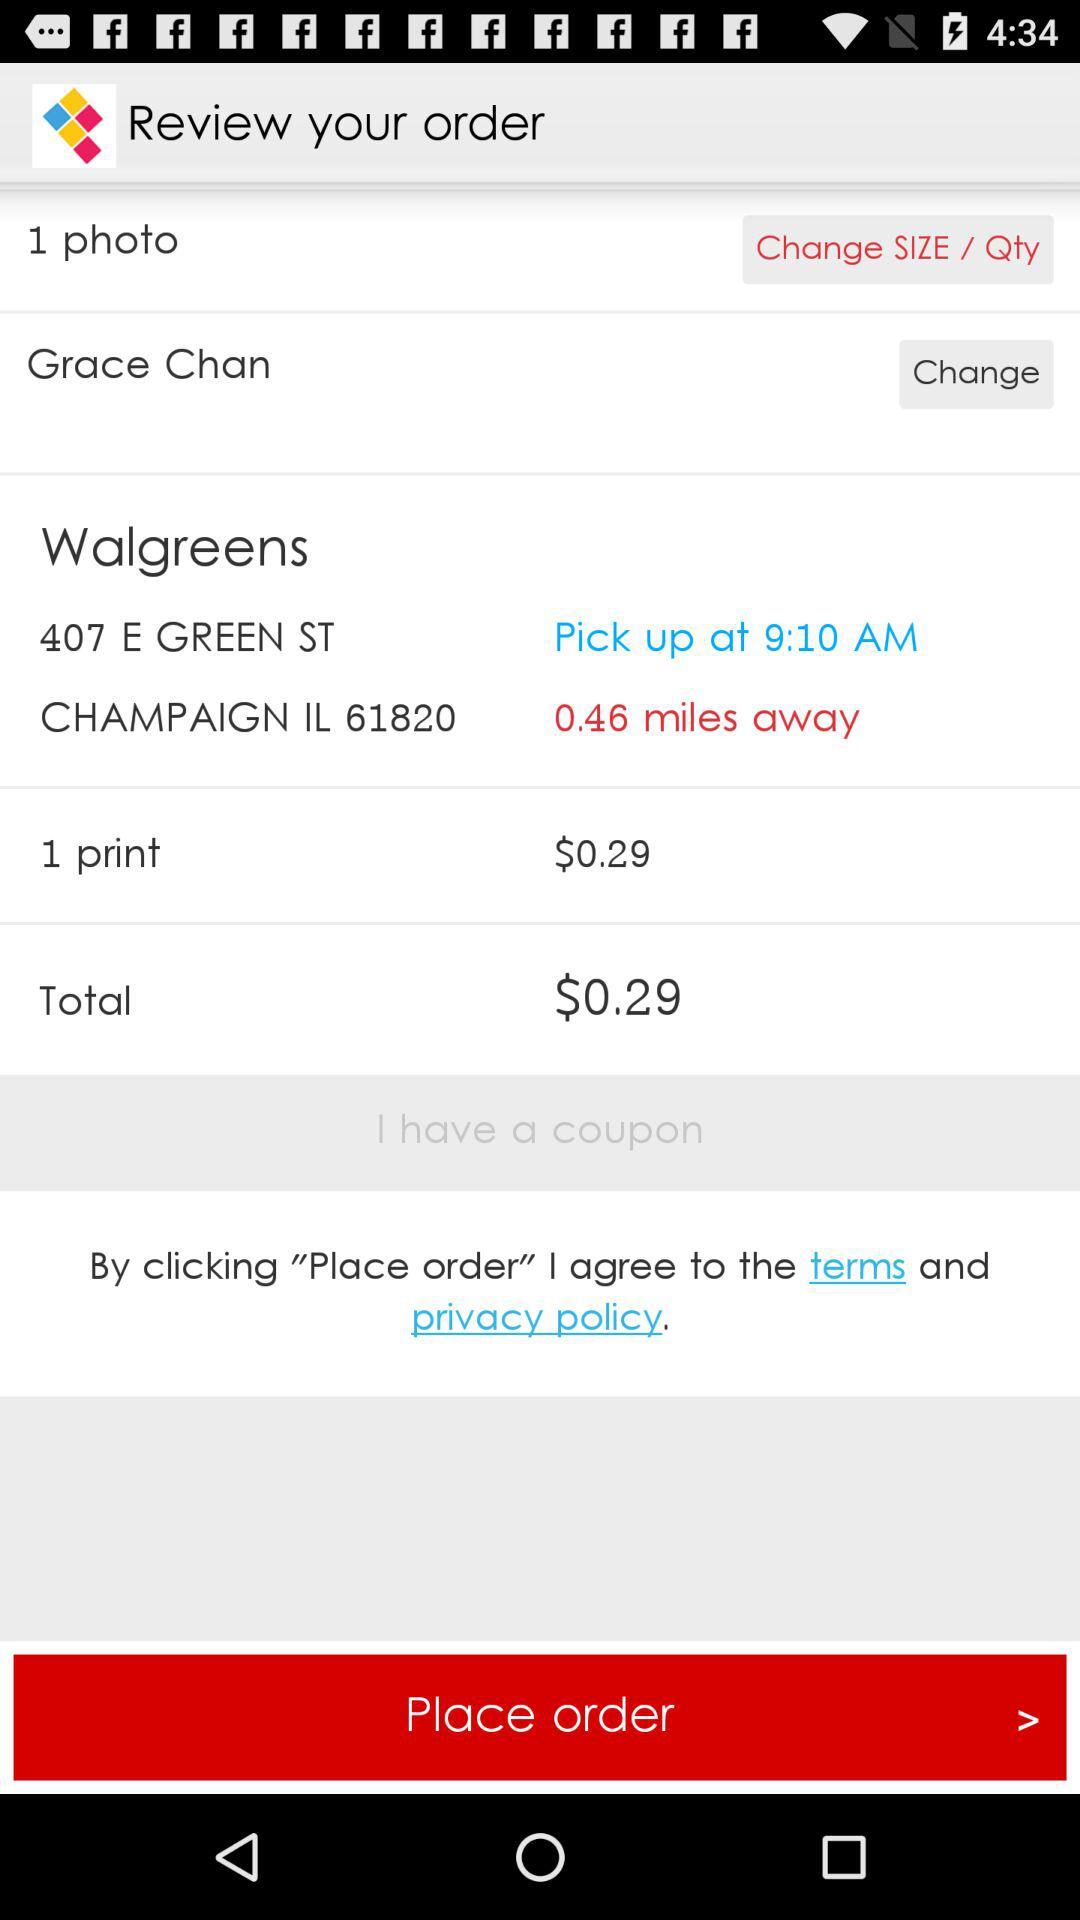What is the location? The location is 407 E Green St. Champaign, IL 61820. 